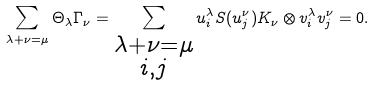Convert formula to latex. <formula><loc_0><loc_0><loc_500><loc_500>\sum _ { \lambda + \nu = \mu } \Theta _ { \lambda } \Gamma _ { \nu } = \sum _ { \substack { \lambda + \nu = \mu \\ i , j } } u _ { i } ^ { \lambda } S ( u _ { j } ^ { \nu } ) K _ { \nu } \otimes v _ { i } ^ { \lambda } v _ { j } ^ { \nu } = 0 .</formula> 